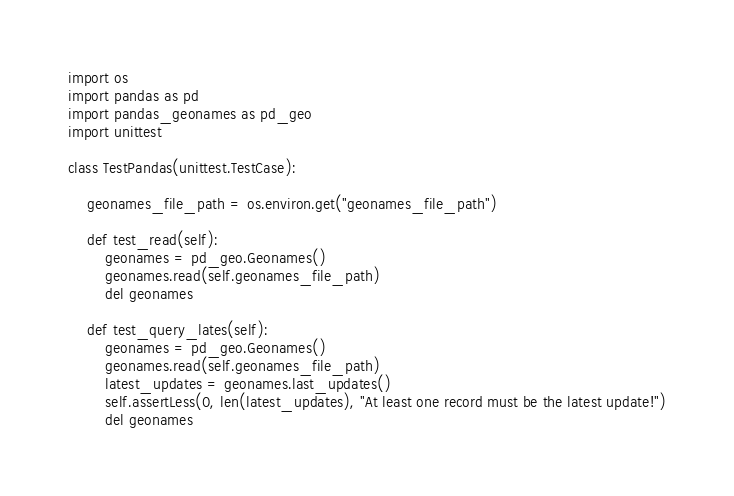<code> <loc_0><loc_0><loc_500><loc_500><_Python_>import os
import pandas as pd
import pandas_geonames as pd_geo
import unittest

class TestPandas(unittest.TestCase):

    geonames_file_path = os.environ.get("geonames_file_path")

    def test_read(self):
        geonames = pd_geo.Geonames()
        geonames.read(self.geonames_file_path)
        del geonames

    def test_query_lates(self):
        geonames = pd_geo.Geonames()
        geonames.read(self.geonames_file_path)
        latest_updates = geonames.last_updates()
        self.assertLess(0, len(latest_updates), "At least one record must be the latest update!")
        del geonames</code> 